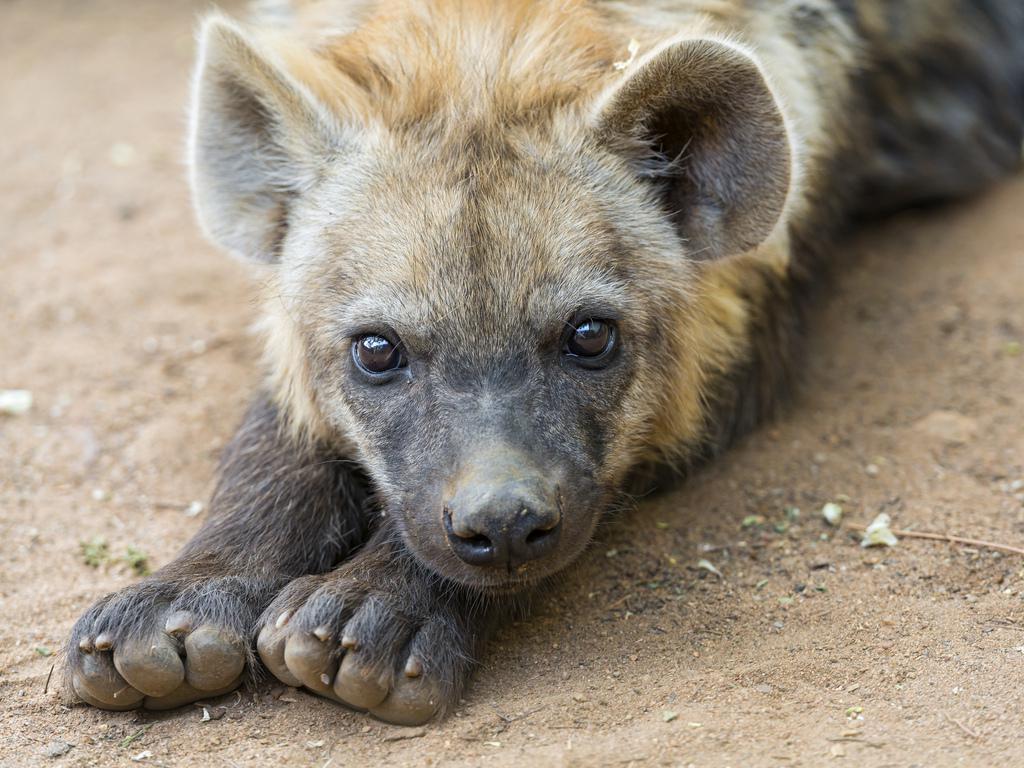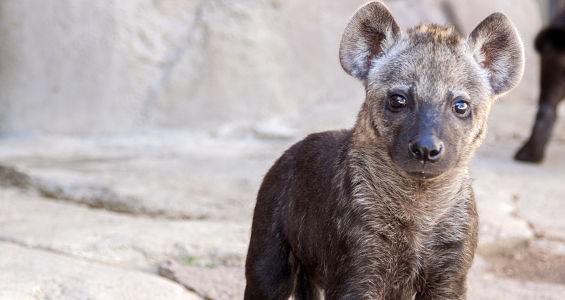The first image is the image on the left, the second image is the image on the right. For the images displayed, is the sentence "An image shows a dark baby hyena posed with its head over the ear of a reclining adult hyena." factually correct? Answer yes or no. No. The first image is the image on the left, the second image is the image on the right. Analyze the images presented: Is the assertion "The left image contains two hyenas." valid? Answer yes or no. No. 